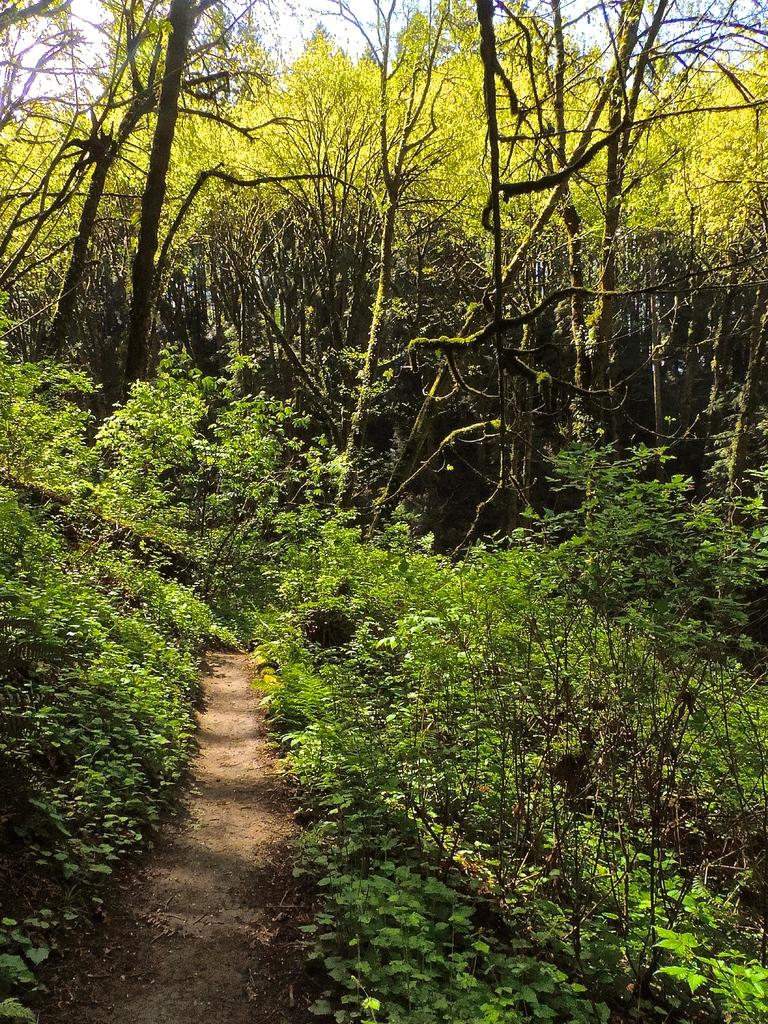What type of vegetation is visible in the image? There are trees and plants visible in the image. Can you describe the path in the image? Yes, there is a path in the middle of the image. Where are the pigs located in the image? There are no pigs present in the image. What type of cart can be seen being pulled by the pigs in the image? There is no cart or pigs present in the image. 